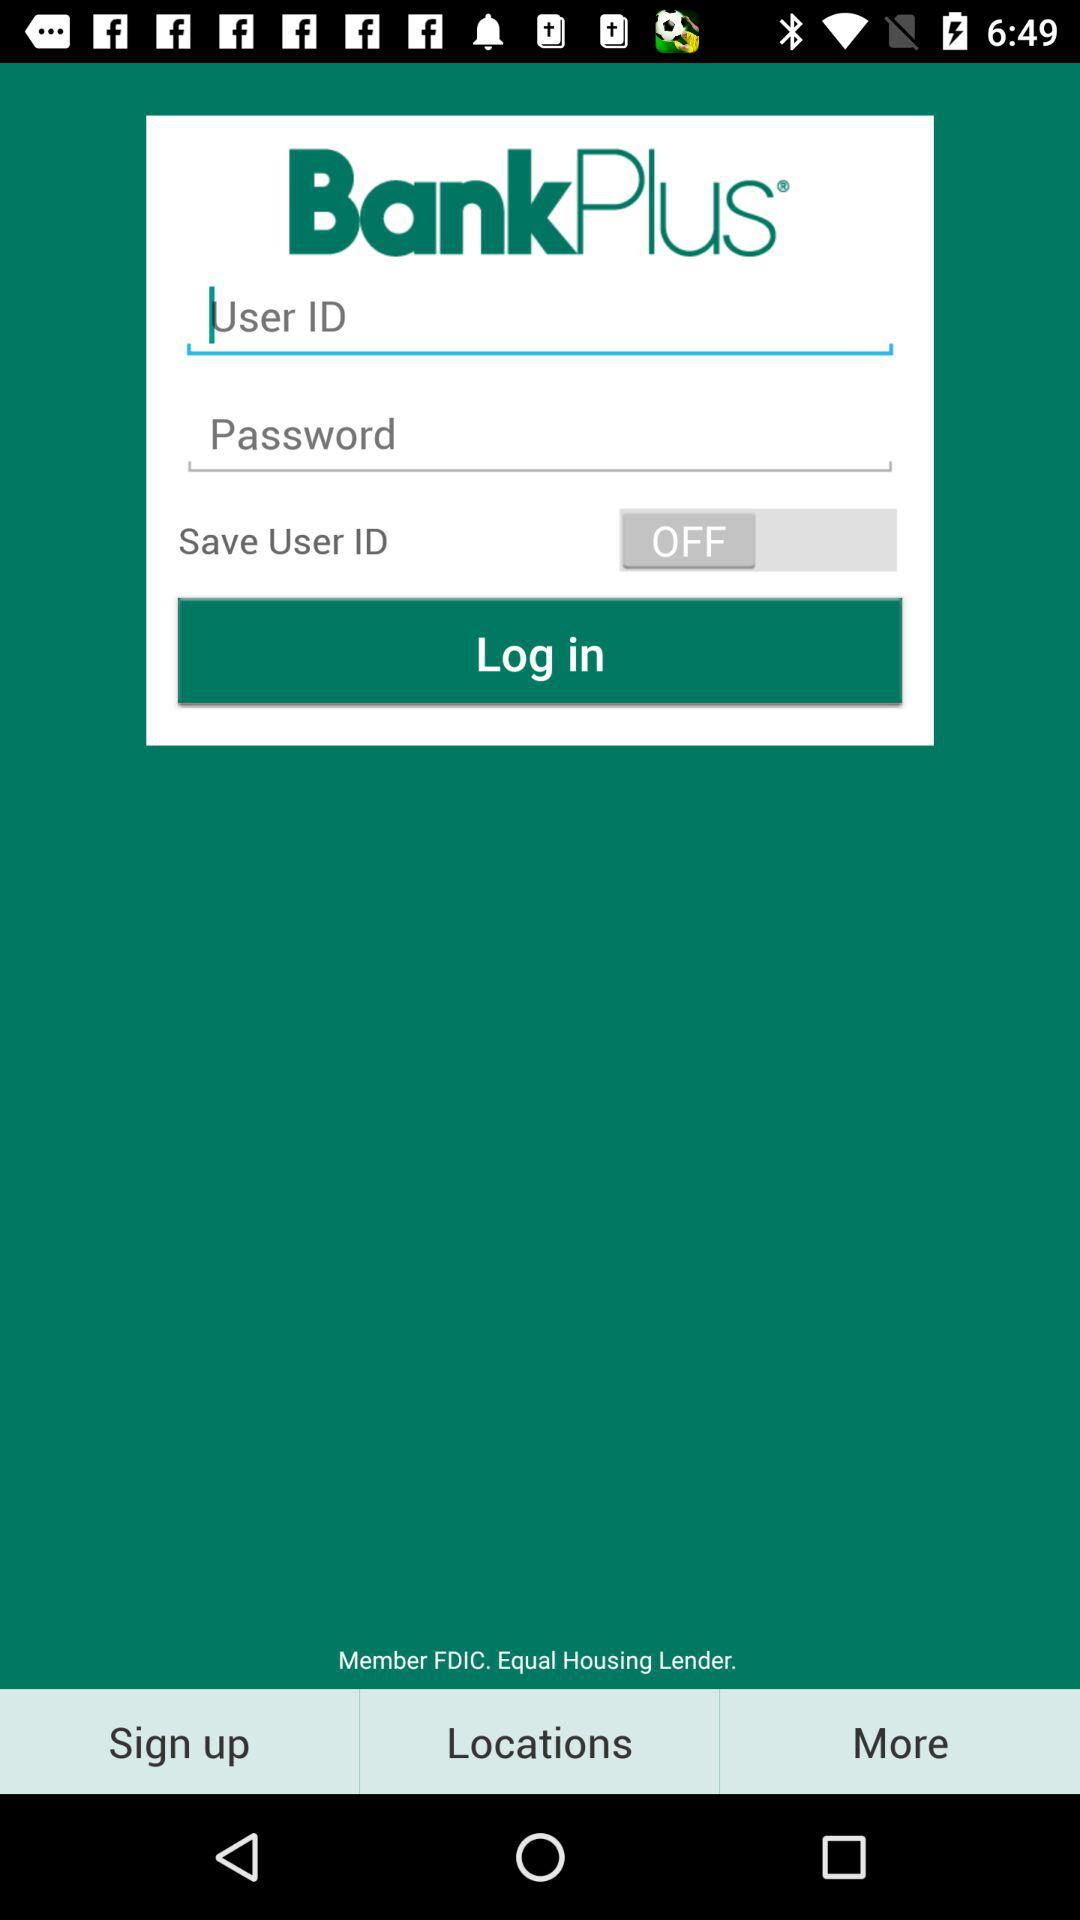What is the name of the application? The name of the application is BankPlus. 